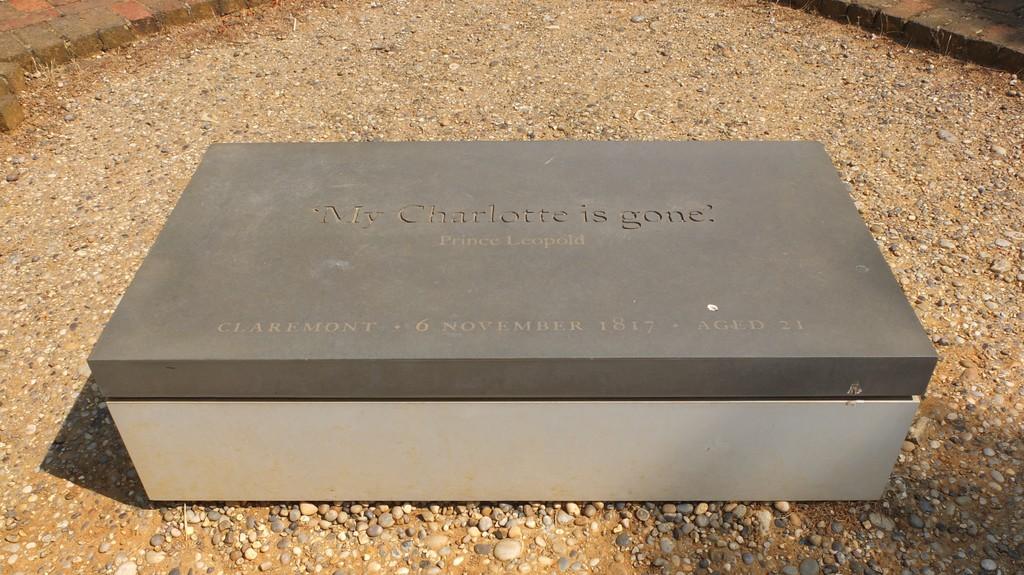Which prince does the gravestone refer to?
Provide a succinct answer. Unanswerable. 